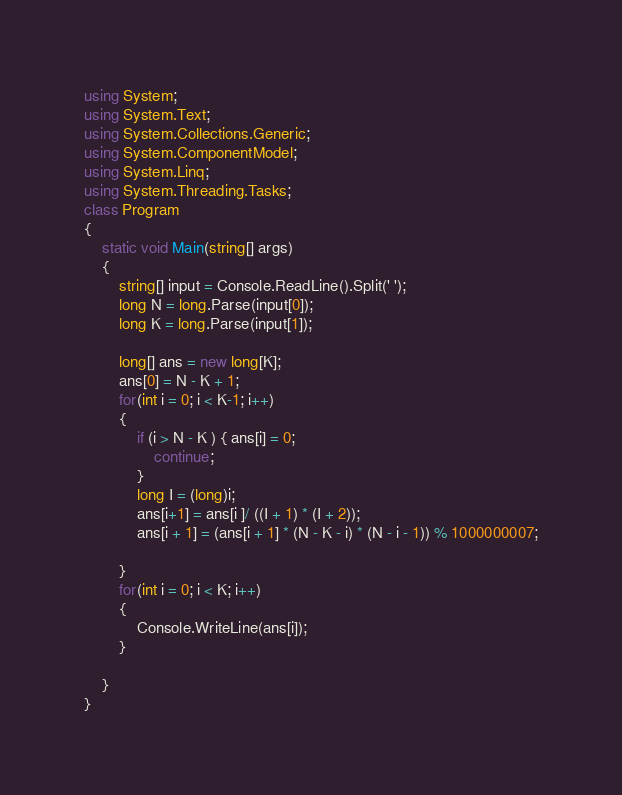Convert code to text. <code><loc_0><loc_0><loc_500><loc_500><_C#_>using System;
using System.Text;
using System.Collections.Generic;
using System.ComponentModel;
using System.Linq;
using System.Threading.Tasks;
class Program
{
	static void Main(string[] args)
	{
		string[] input = Console.ReadLine().Split(' ');
		long N = long.Parse(input[0]);
		long K = long.Parse(input[1]);

		long[] ans = new long[K];
		ans[0] = N - K + 1;
        for(int i = 0; i < K-1; i++)
		{
			if (i > N - K ) { ans[i] = 0;
				continue;
			}
			long I = (long)i;
			ans[i+1] = ans[i ]/ ((I + 1) * (I + 2));
			ans[i + 1] = (ans[i + 1] * (N - K - i) * (N - i - 1)) % 1000000007;
            
		}
        for(int i = 0; i < K; i++)
		{
			Console.WriteLine(ans[i]);
		}
        
    }
}</code> 